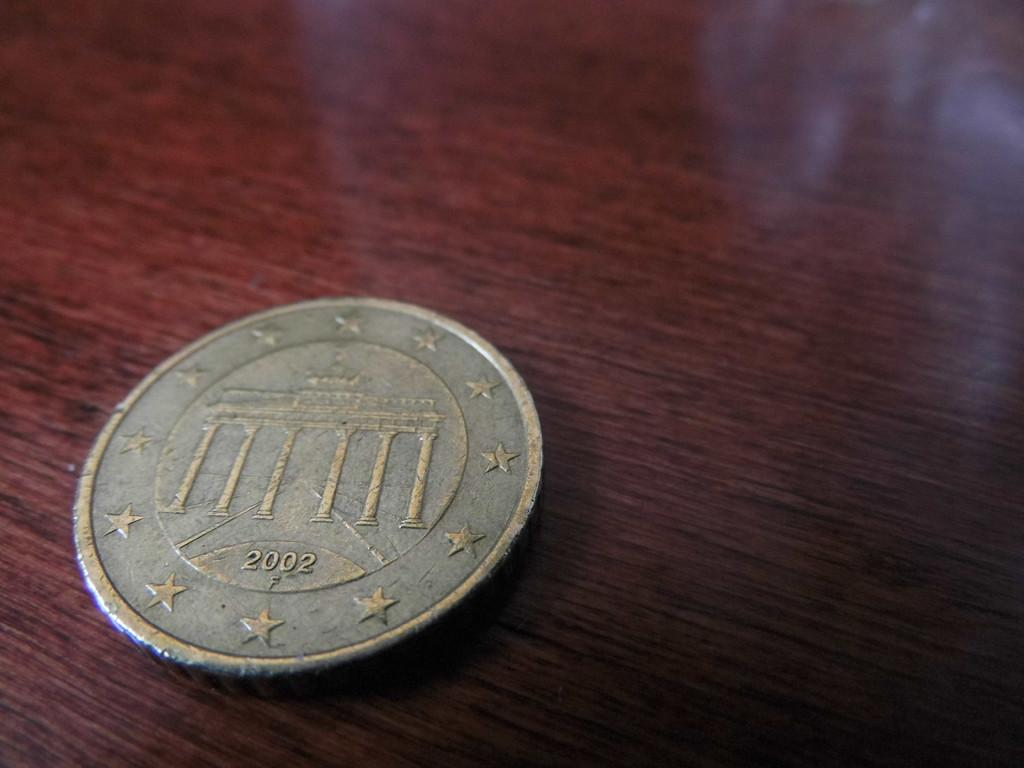<image>
Present a compact description of the photo's key features. A faded coin with a 2002 date sites on a table. 